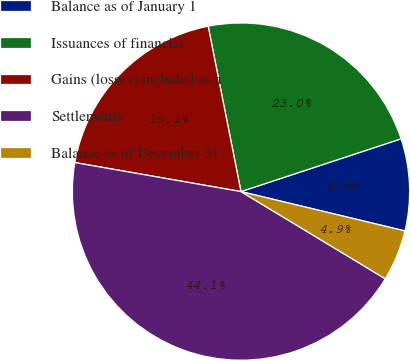<chart> <loc_0><loc_0><loc_500><loc_500><pie_chart><fcel>Balance as of January 1<fcel>Issuances of financial<fcel>Gains (losses) included as a<fcel>Settlements<fcel>Balance as of December 31<nl><fcel>8.82%<fcel>23.05%<fcel>19.13%<fcel>44.1%<fcel>4.9%<nl></chart> 